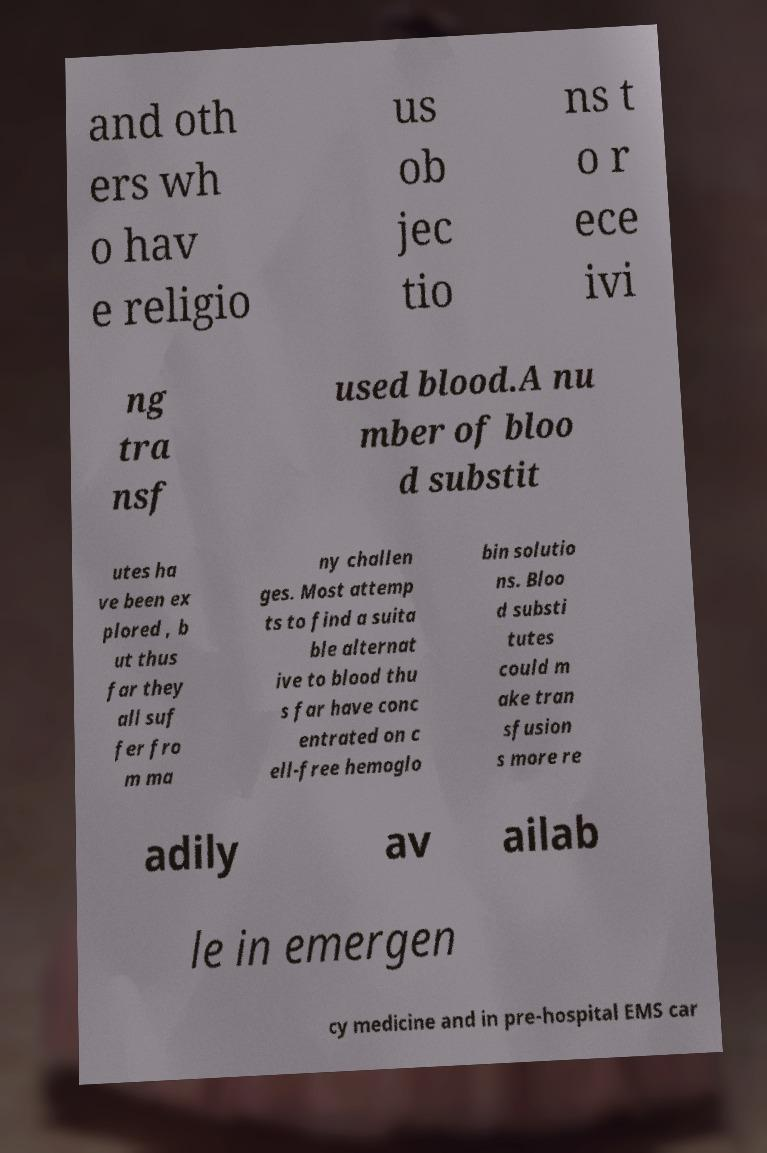Could you assist in decoding the text presented in this image and type it out clearly? and oth ers wh o hav e religio us ob jec tio ns t o r ece ivi ng tra nsf used blood.A nu mber of bloo d substit utes ha ve been ex plored , b ut thus far they all suf fer fro m ma ny challen ges. Most attemp ts to find a suita ble alternat ive to blood thu s far have conc entrated on c ell-free hemoglo bin solutio ns. Bloo d substi tutes could m ake tran sfusion s more re adily av ailab le in emergen cy medicine and in pre-hospital EMS car 